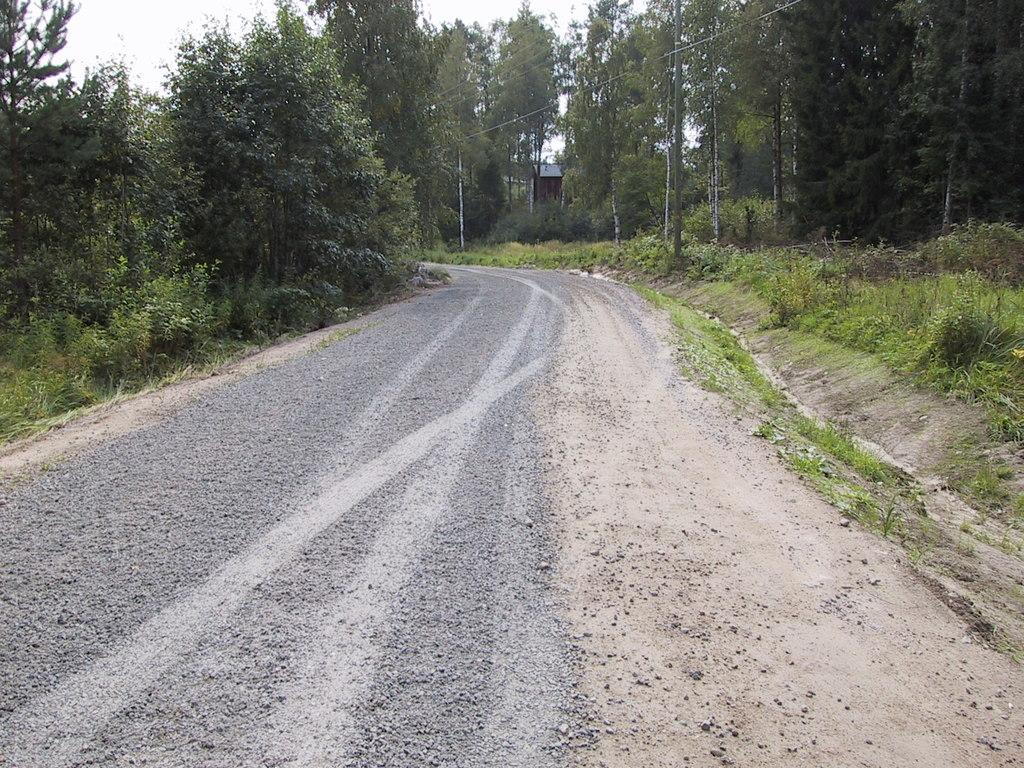What type of vegetation can be seen in the image? There are trees in the image. What type of surface is visible in the image? There is a road and grass in the image. What part of the natural environment is visible in the image? The sky is visible in the image. How many bikes are parked on the mountain in the image? There is no mountain or bikes present in the image. 